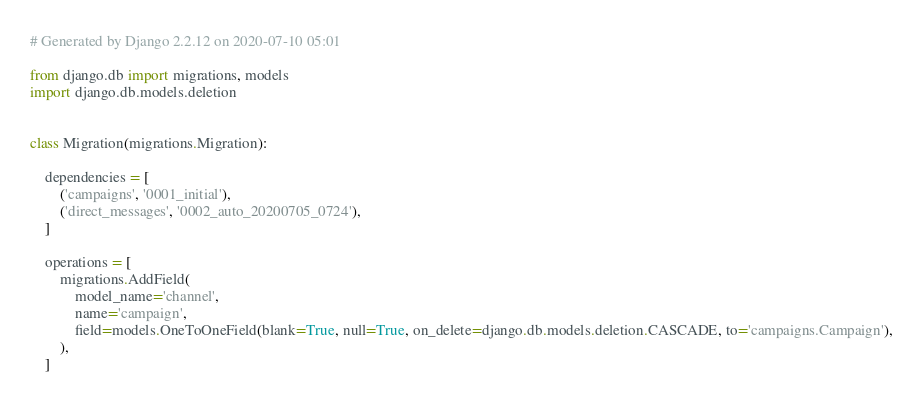<code> <loc_0><loc_0><loc_500><loc_500><_Python_># Generated by Django 2.2.12 on 2020-07-10 05:01

from django.db import migrations, models
import django.db.models.deletion


class Migration(migrations.Migration):

    dependencies = [
        ('campaigns', '0001_initial'),
        ('direct_messages', '0002_auto_20200705_0724'),
    ]

    operations = [
        migrations.AddField(
            model_name='channel',
            name='campaign',
            field=models.OneToOneField(blank=True, null=True, on_delete=django.db.models.deletion.CASCADE, to='campaigns.Campaign'),
        ),
    ]
</code> 